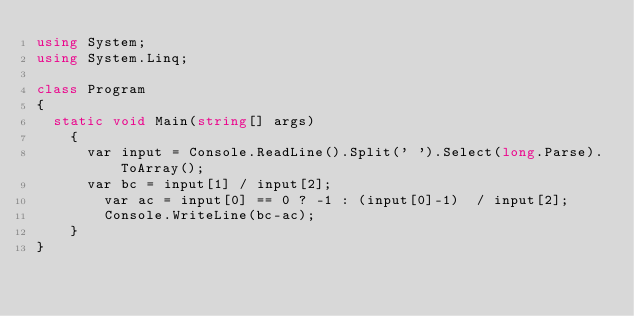Convert code to text. <code><loc_0><loc_0><loc_500><loc_500><_C#_>using System;
using System.Linq;

class Program
{
	static void Main(string[] args)
    {
    	var input = Console.ReadLine().Split(' ').Select(long.Parse).ToArray();
   		var bc = input[1] / input[2];
        var ac = input[0] == 0 ? -1 : (input[0]-1)  / input[2];
        Console.WriteLine(bc-ac);
    }
}</code> 